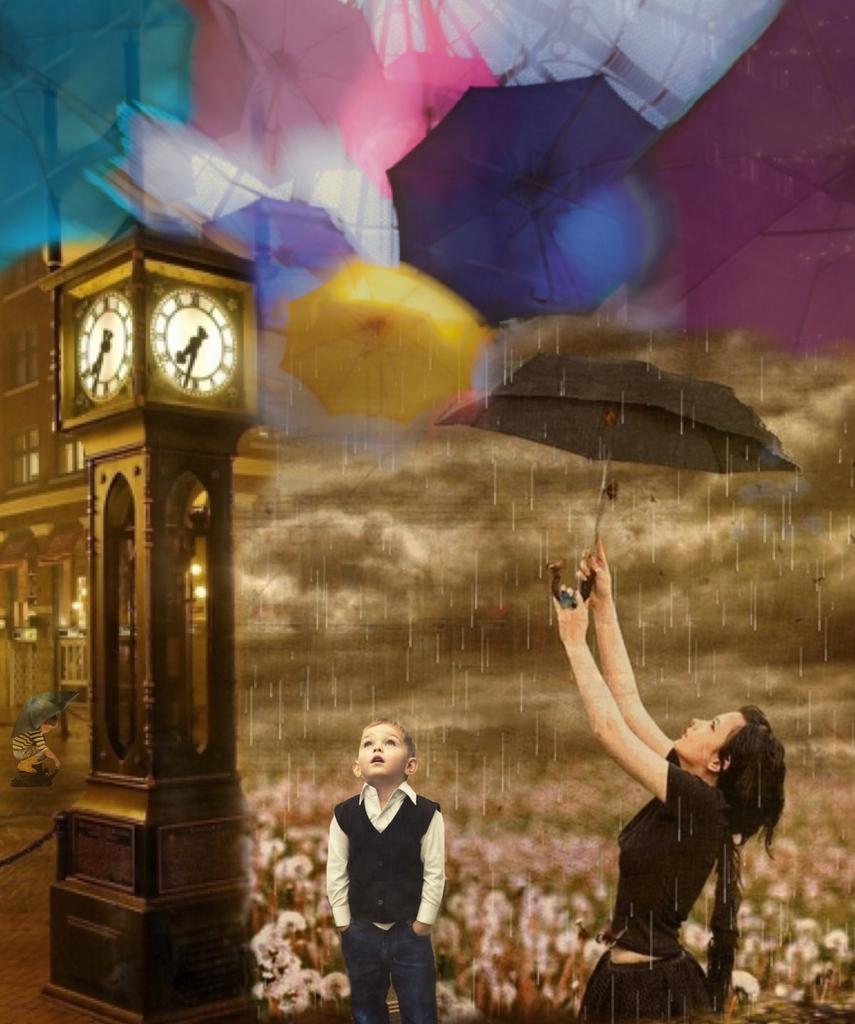Could you give a brief overview of what you see in this image? In the center of the picture there is a kid. On the right there is a woman in black dress holding an umbrella. At the top there are umbrellas. On the left there is a clock tower and building and there is a kid holding an umbrella. In the background there are flowers. In the center of the picture there are clouds and it is raining. This is an edited image. 